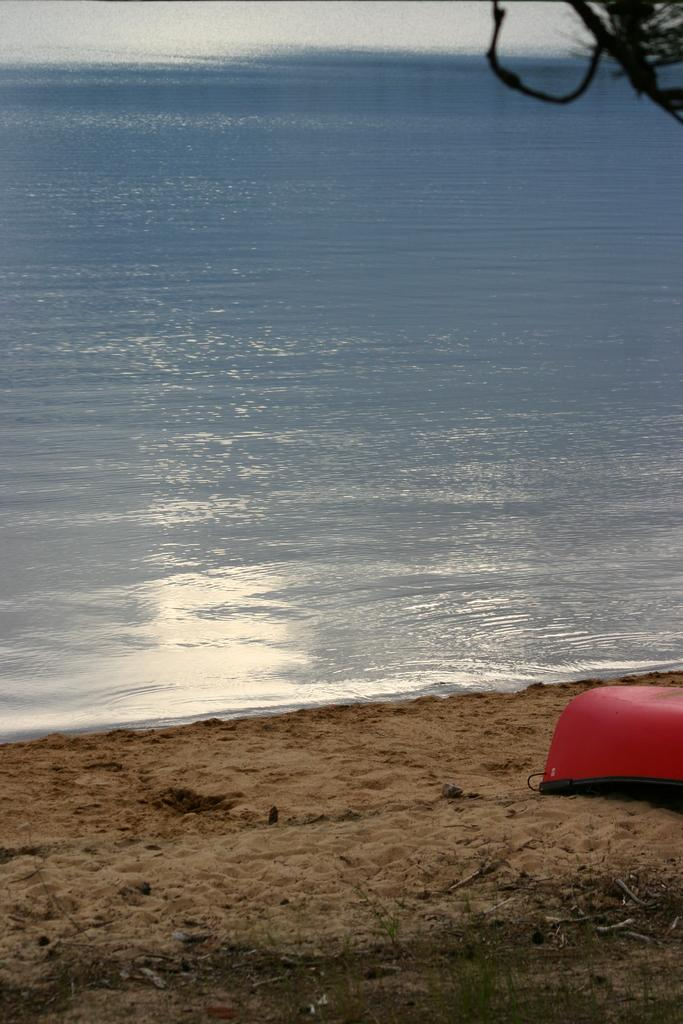What type of terrain is visible in the image? There is sand in the image. What else can be seen in the image besides sand? There is water in the image. Can you describe the color of any objects in the image? There is an object in the image that is red in color. What type of squirrel can be seen wearing a shirt and holding a locket in the image? There is no squirrel, shirt, or locket present in the image. 